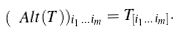Convert formula to latex. <formula><loc_0><loc_0><loc_500><loc_500>( \ A l t ( T ) ) _ { i _ { 1 } \dots i _ { m } } = T _ { [ i _ { 1 } \dots i _ { m } ] } .</formula> 